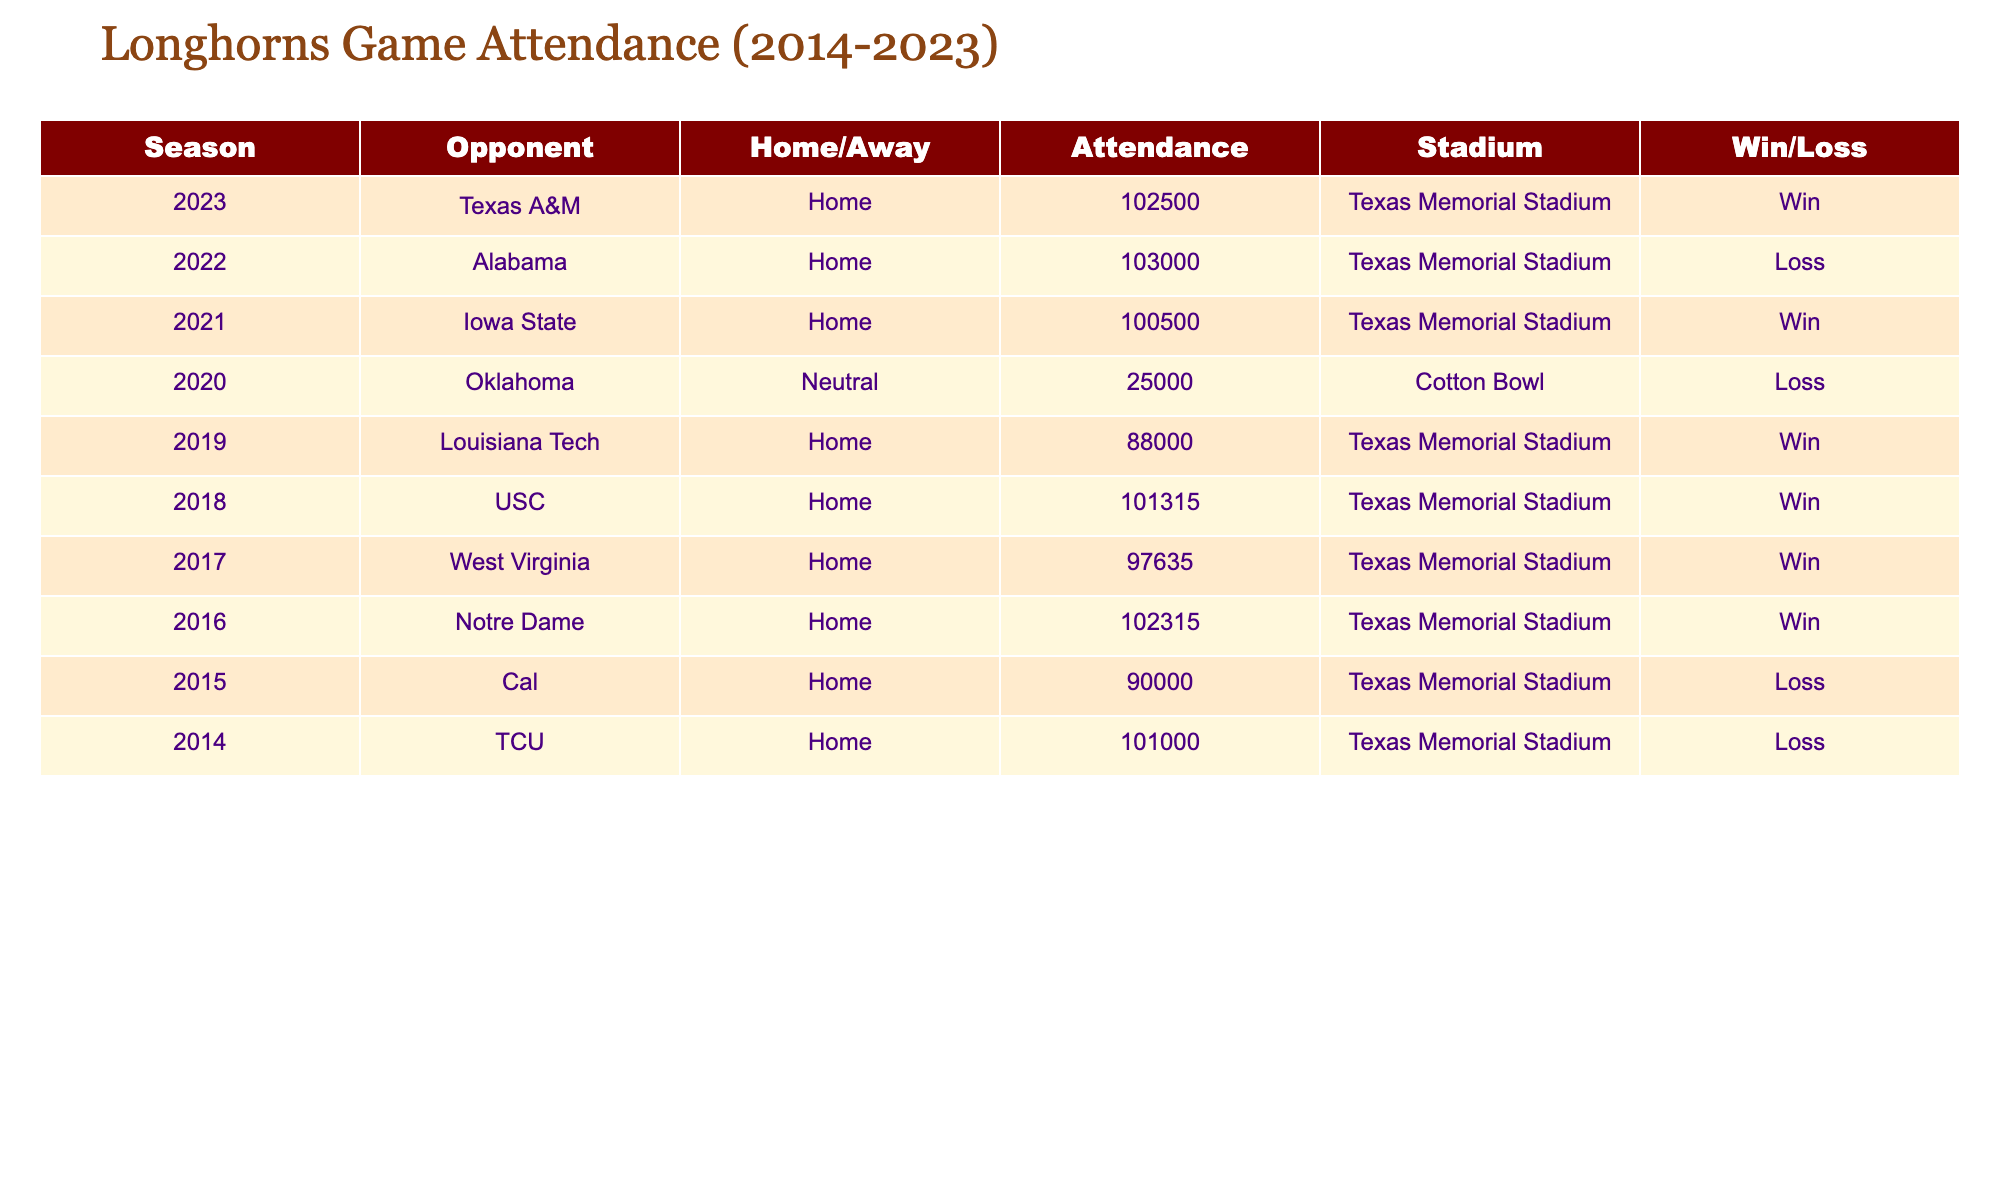What was the highest attendance recorded in the years 2018 to 2023? The highest attendance can be found by scanning the Attendance column for the maximum value. From the data, the highest attendance is 103000, which occurred during the 2022 game against Alabama.
Answer: 103000 How many games did the Longhorns host in Texas Memorial Stadium from 2014 to 2023? To find the number of home games, count the rows where the Home/Away status is "Home." Checking the data reveals that there are 8 home games in total from 2014 to 2023.
Answer: 8 Did the Longhorns win their game against USC in 2018? To answer this, we need to check the Win/Loss column for the 2018 game, which shows it as a "Win." Therefore, they did win against USC.
Answer: Yes What was the average attendance for the games where the Longhorns lost? First, identify the losses from the Win/Loss column: they lost games against Oklahoma (2020), Alabama (2022), Cal (2015), and TCU (2014). Their attendances are 25000, 103000, 90000, and 101000 respectively. Sum these attendances: 25000 + 103000 + 90000 + 101000 = 320000. This total is then divided by the number of losses (4) to find the average: 320000 / 4 = 80000.
Answer: 80000 Which season had the second highest attendance and what was the figure? To find this, list the attendance in descending order: 103000 (2022), 102500 (2023), 102315 (2016), and so on. The second highest attendance is therefore 102500 in the 2023 season against Texas A&M.
Answer: 102500 